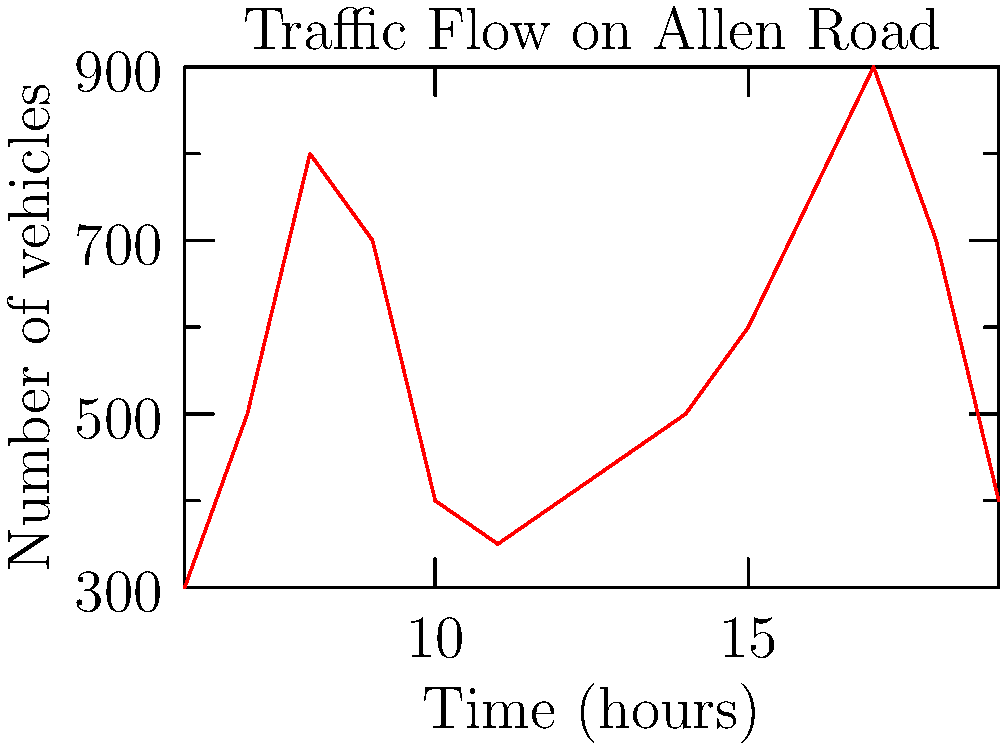Based on the traffic flow graph for Allen Road, during which hour does the evening rush hour peak occur? To determine the evening rush hour peak on Allen Road:

1. Identify the time range for evening hours (typically after 3 PM or 15:00).
2. Locate the highest point on the graph within this time range.
3. Find the corresponding time (x-axis) for this peak.

Steps:
1. Evening hours start from 15:00 (3 PM) onwards.
2. Examining the graph from 15:00, we see the traffic flow increasing.
3. The highest point in the evening occurs at 17:00 (5 PM).
4. After 17:00, the traffic flow starts to decrease.

Therefore, the evening rush hour peak occurs at 17:00 (5 PM).
Answer: 17:00 (5 PM) 